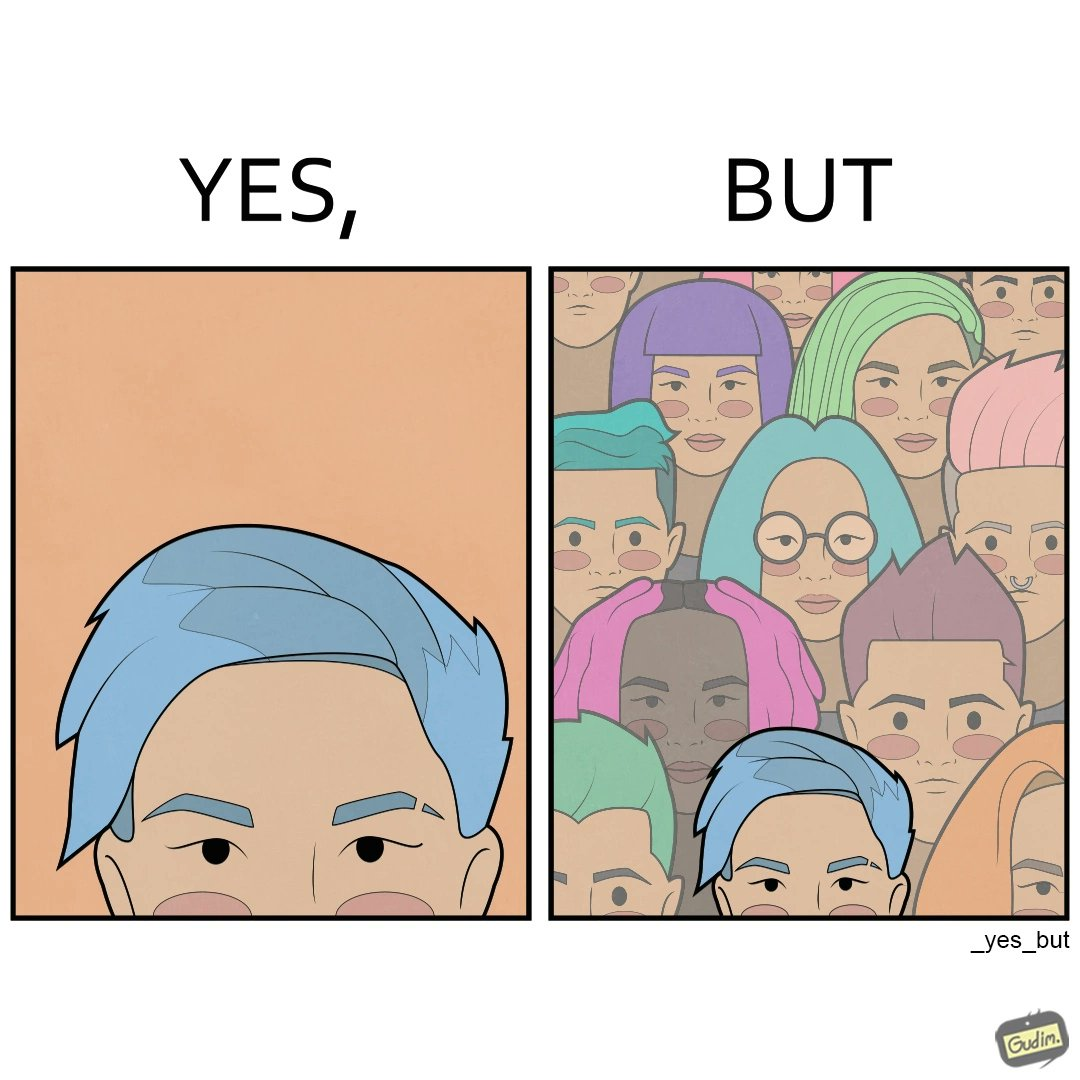What does this image depict? The image is funny, as one person with a hair dyed blue seems to symbolize that the person is going against the grain, however, when we zoom out, the group of people have hair dyed in several, different colors, showing that, dyeing hair is the new normal. 